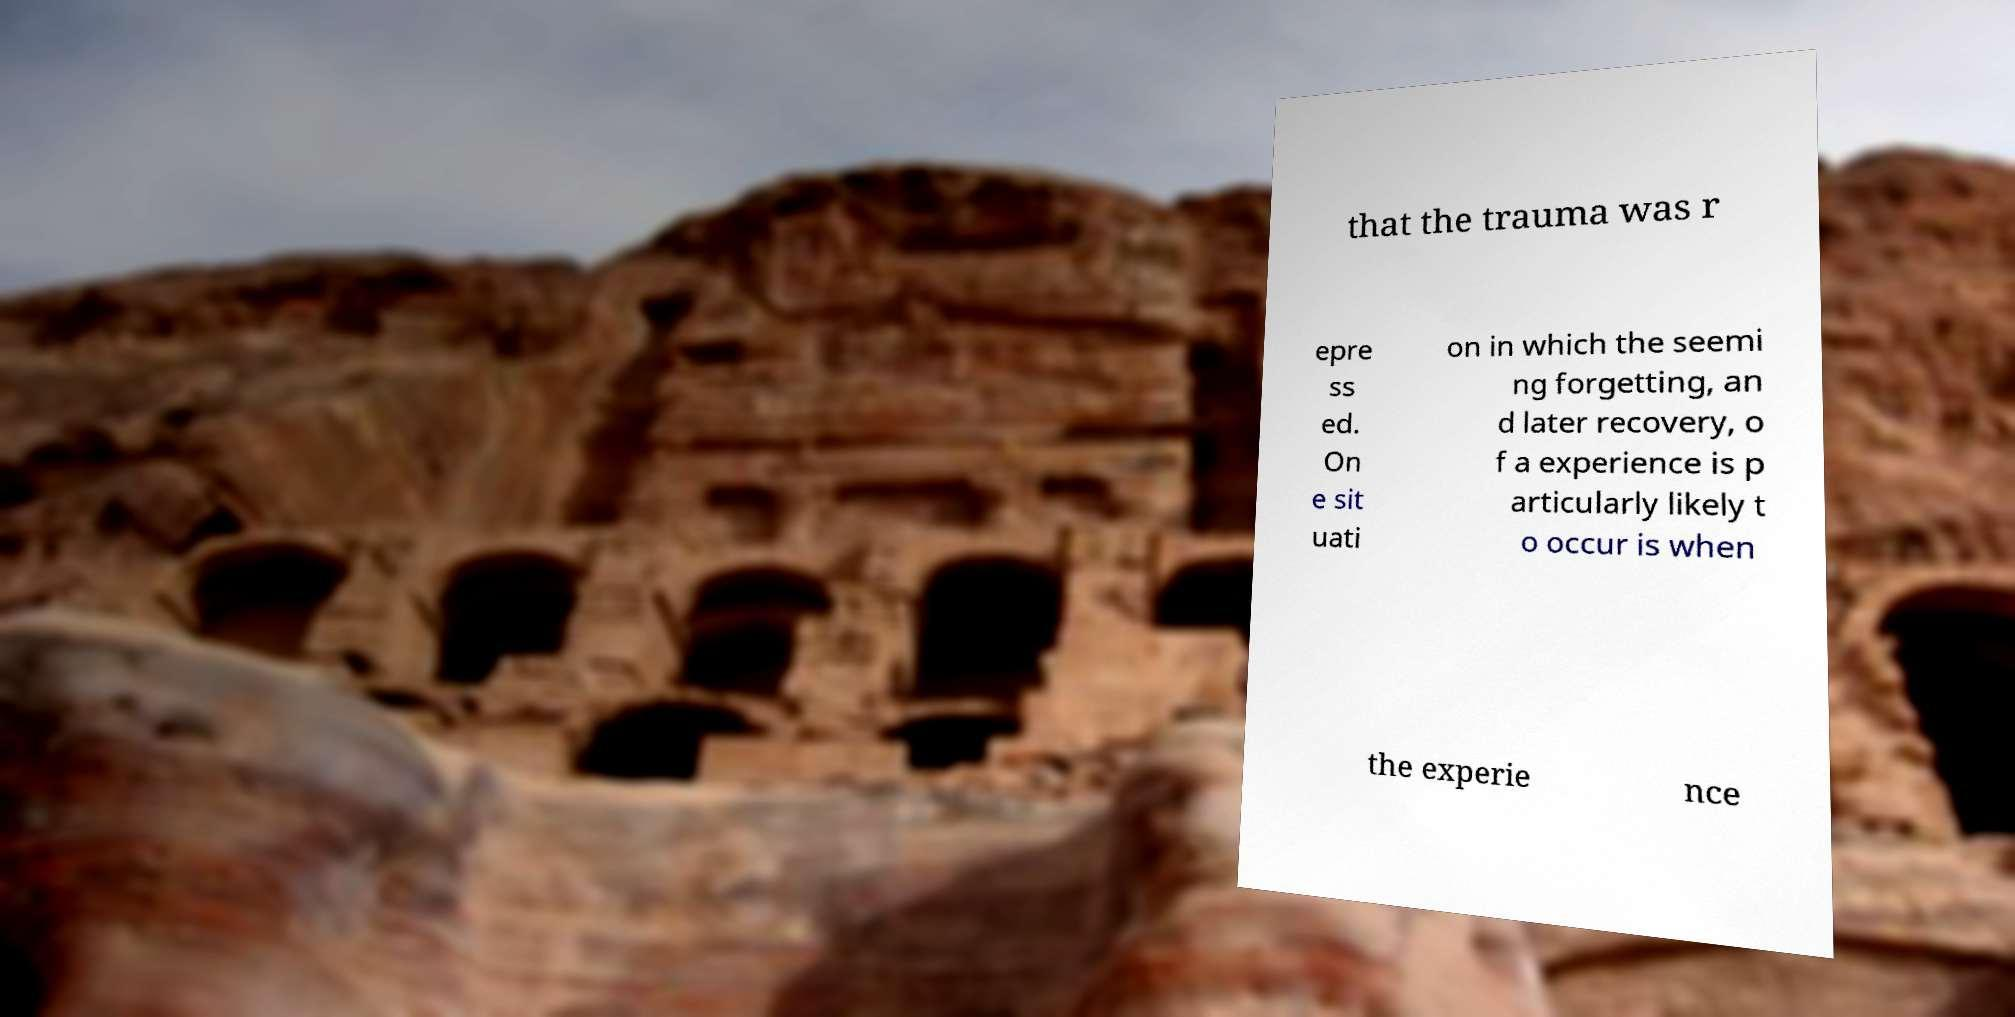Could you extract and type out the text from this image? that the trauma was r epre ss ed. On e sit uati on in which the seemi ng forgetting, an d later recovery, o f a experience is p articularly likely t o occur is when the experie nce 